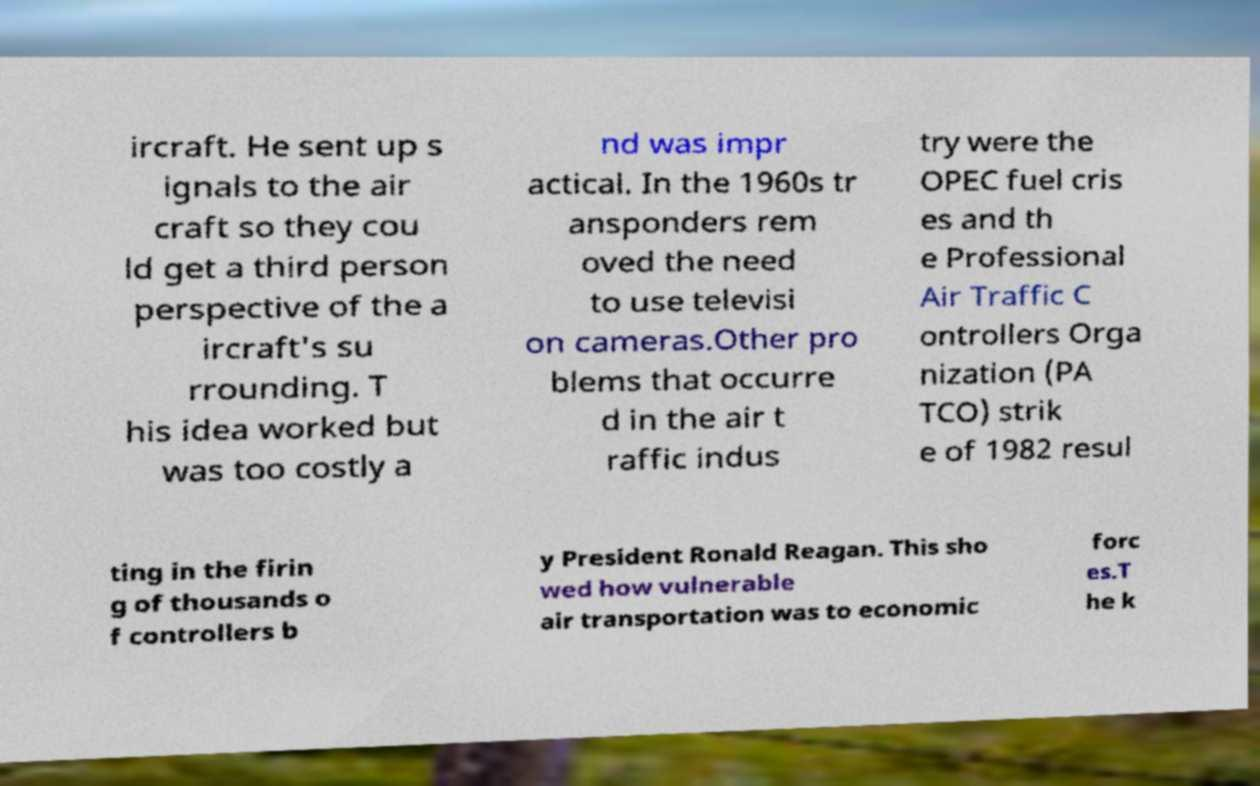Could you assist in decoding the text presented in this image and type it out clearly? ircraft. He sent up s ignals to the air craft so they cou ld get a third person perspective of the a ircraft's su rrounding. T his idea worked but was too costly a nd was impr actical. In the 1960s tr ansponders rem oved the need to use televisi on cameras.Other pro blems that occurre d in the air t raffic indus try were the OPEC fuel cris es and th e Professional Air Traffic C ontrollers Orga nization (PA TCO) strik e of 1982 resul ting in the firin g of thousands o f controllers b y President Ronald Reagan. This sho wed how vulnerable air transportation was to economic forc es.T he k 